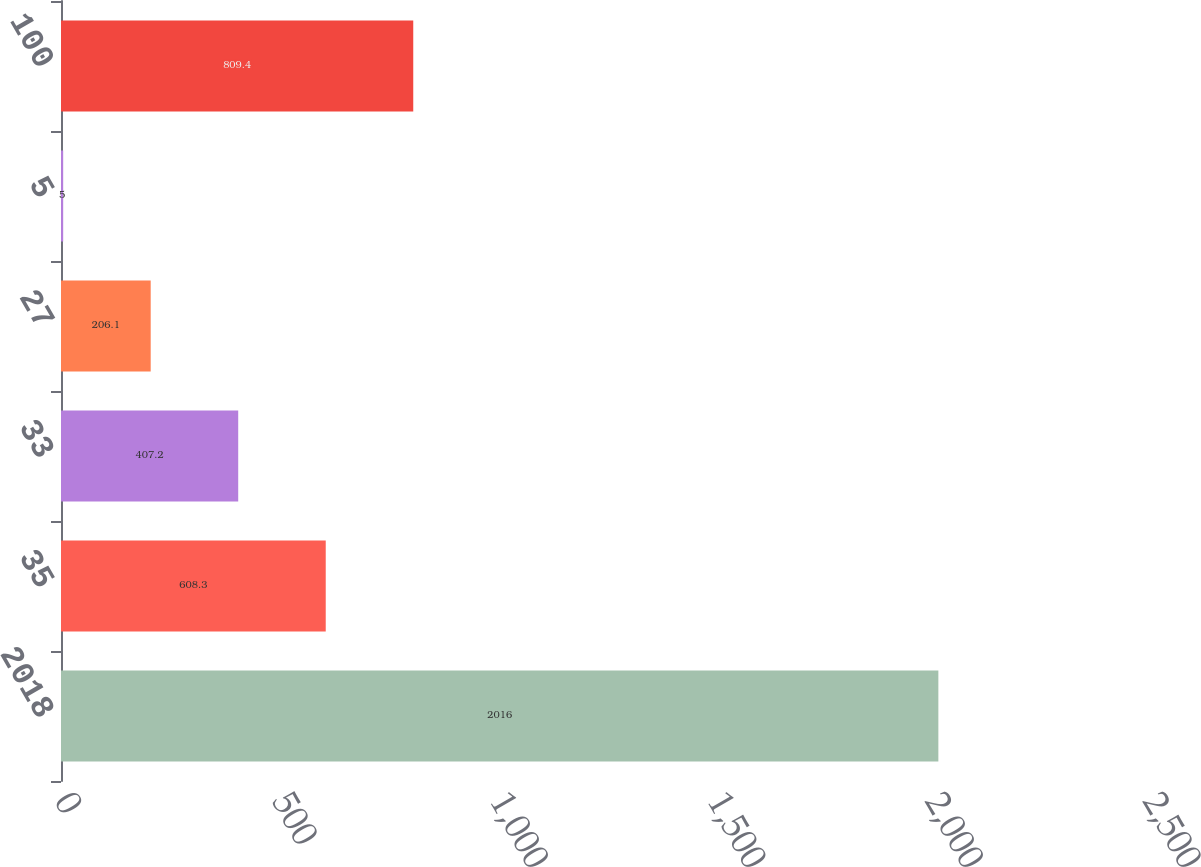Convert chart to OTSL. <chart><loc_0><loc_0><loc_500><loc_500><bar_chart><fcel>2018<fcel>35<fcel>33<fcel>27<fcel>5<fcel>100<nl><fcel>2016<fcel>608.3<fcel>407.2<fcel>206.1<fcel>5<fcel>809.4<nl></chart> 